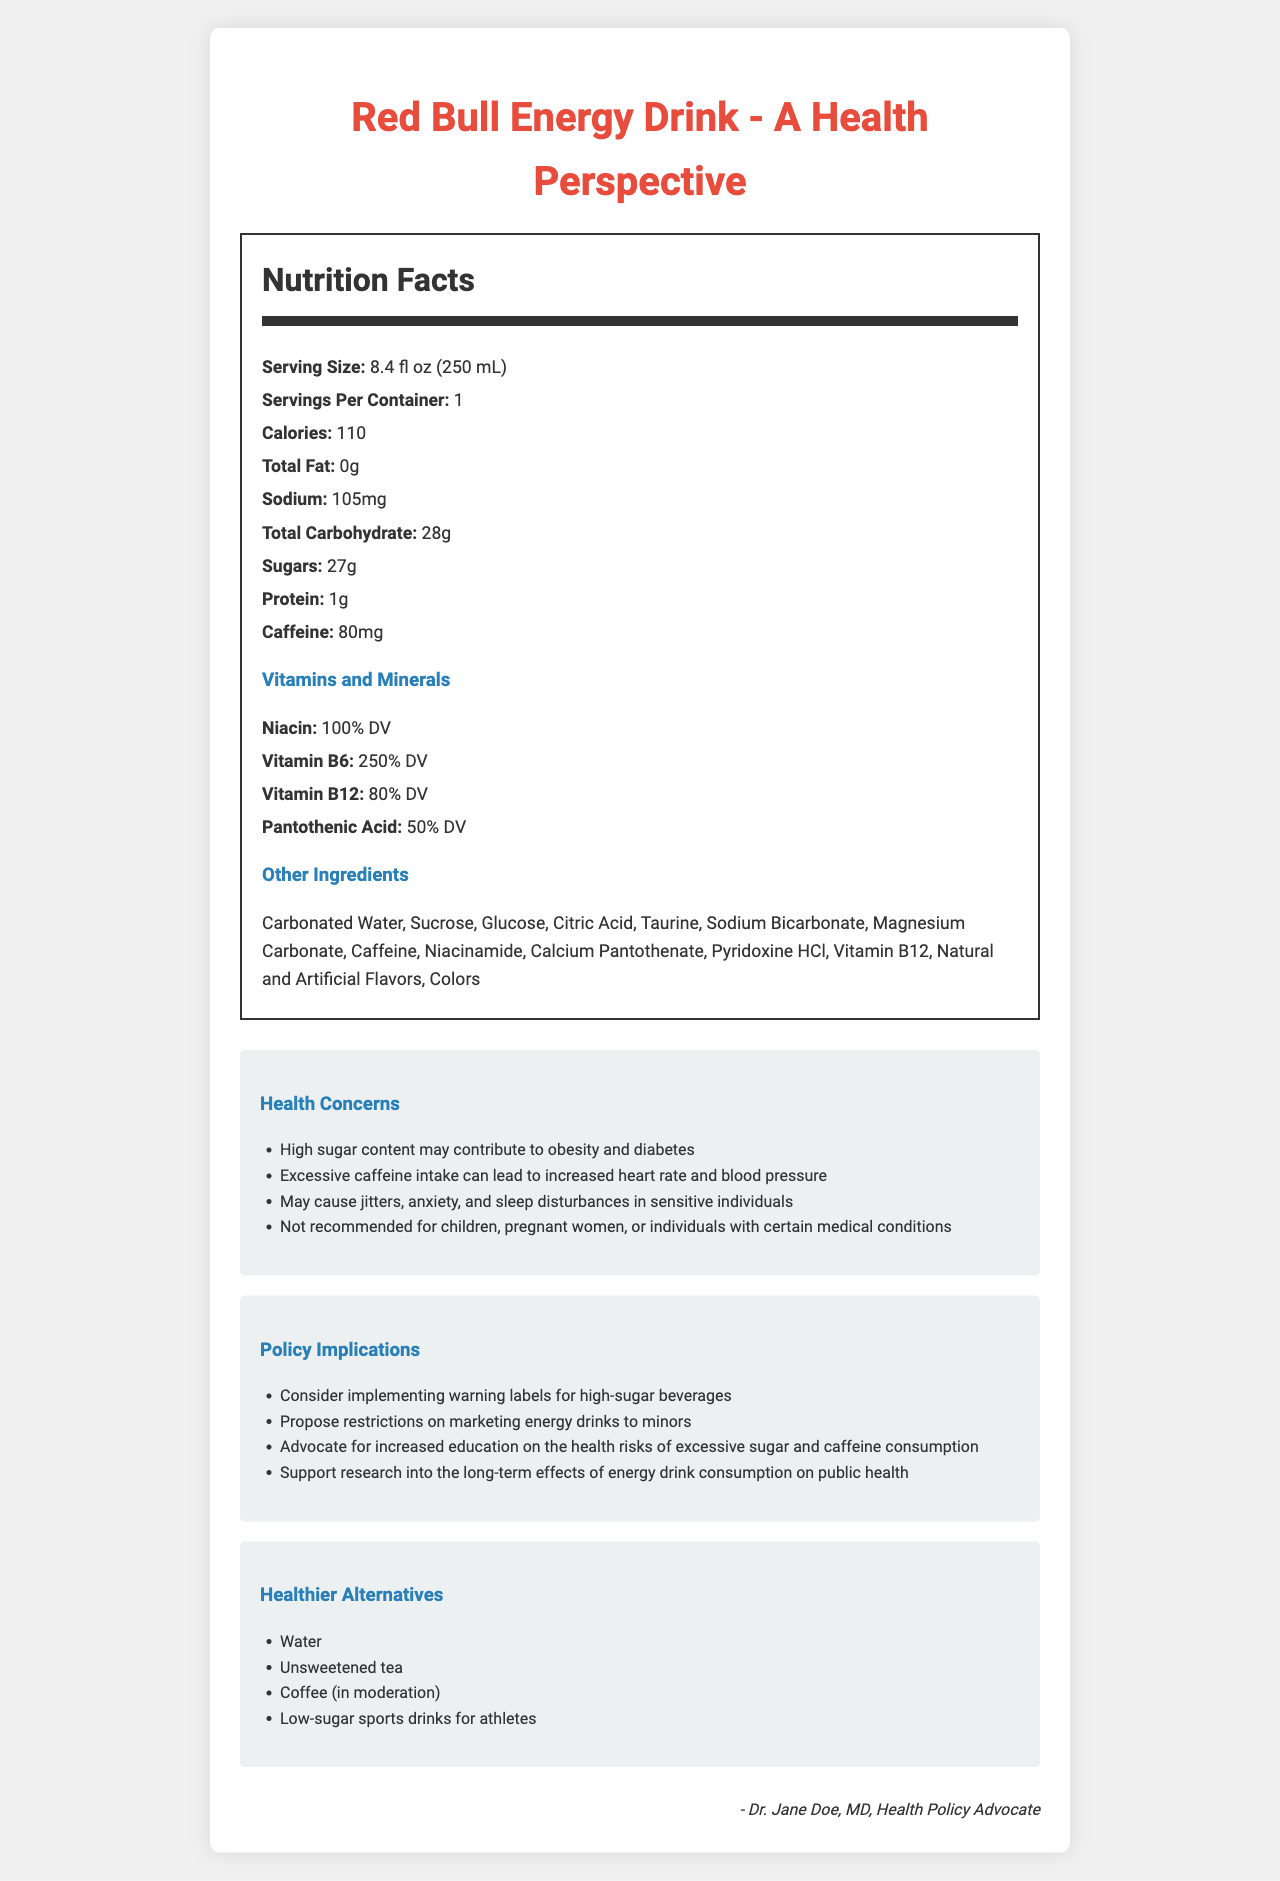what is the serving size of the Red Bull Energy Drink? The serving size is provided in the Nutrition Facts section of the document.
Answer: 8.4 fl oz (250 mL) how many grams of sugar does one serving of Red Bull Energy Drink contain? The amount of sugars is listed in the Nutrition Facts section under Total Carbohydrate.
Answer: 27g What is the total amount of caffeine per serving? The caffeine content per serving is shown in the Nutrition Facts section.
Answer: 80mg How many calories are in one serving of Red Bull Energy Drink? The calories per serving are provided in the Nutrition Facts section.
Answer: 110 What are the vitamins and their respective daily values found in the energy drink? The vitamins and their daily values are listed in the Vitamins and Minerals section of the Nutrition Facts.
Answer: Niacin: 100% DV, Vitamin B6: 250% DV, Vitamin B12: 80% DV, Pantothenic Acid: 50% DV What is the main health concern related to the sugar content in the energy drink? A. Increased risk of dental cavities B. Weight gain C. Heart disease D. Diabetes The Health Concerns section states that high sugar content may contribute to obesity and diabetes.
Answer: D. Diabetes Which group of people is particularly advised not to consume Red Bull Energy Drink? A. Athletes B. Minors C. Office Workers D. Seniors The Health Concerns section mentions that the drink is not recommended for children, pregnant women, or individuals with certain medical conditions.
Answer: B. Minors Does Red Bull Energy Drink contain any protein? The Nutrition Facts section indicates that there is 1g of protein per serving.
Answer: Yes Is the Red Bull Energy Drink suitable for individuals with high blood pressure? The Health Concerns section states that excessive caffeine intake can lead to increased heart rate and blood pressure.
Answer: No What main policy implication is suggested regarding marketing high-sugar beverages? The Policy Implications section suggests proposing restrictions on marketing energy drinks to minors.
Answer: Propose restrictions on marketing energy drinks to minors Please summarize the key points of the document. The summary should cover the nutritional details, health concerns, policy implications, and suggested healthier alternatives, which are all major sections of the document.
Answer: The document discusses the nutritional information of Red Bull Energy Drink, highlighting its high sugar (27g) and caffeine (80mg) content. It includes health concerns such as increased heart rate, blood pressure, and the risk of diabetes. Policy implications include implementing warning labels and restricting marketing to minors. Healthier alternatives like water and unsweetened tea are suggested. how much sodium does one can of Red Bull Energy Drink contain? The sodium content is listed in the Nutrition Facts section.
Answer: 105mg Which vitamin found in the drink has the highest daily value percentage? The Vitamins and Minerals section shows the daily value percentages, with Vitamin B6 having the highest.
Answer: Vitamin B6: 250% DV What is the total amount of carbohydrates in the drink? The total carbohydrate content is listed in the Nutrition Facts section.
Answer: 28g What is taurine, and why is it included in the energy drink? The document lists taurine as an ingredient but does not explain what it is or why it is included.
Answer: Not enough information Is drinking water listed as a healthier alternative to Red Bull Energy Drink? Water is listed in the Healthier Alternatives section.
Answer: Yes 